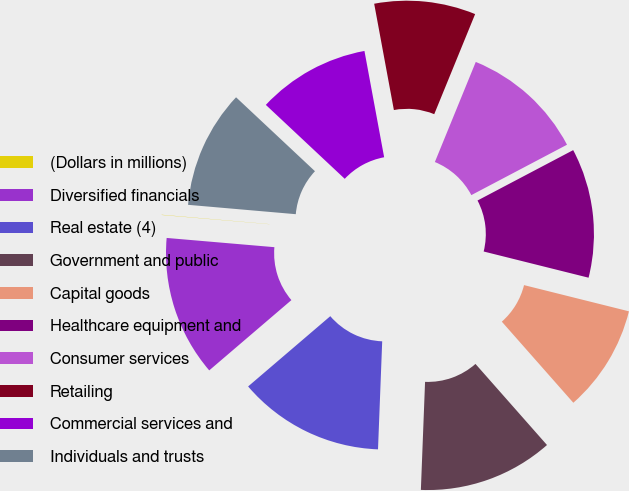<chart> <loc_0><loc_0><loc_500><loc_500><pie_chart><fcel>(Dollars in millions)<fcel>Diversified financials<fcel>Real estate (4)<fcel>Government and public<fcel>Capital goods<fcel>Healthcare equipment and<fcel>Consumer services<fcel>Retailing<fcel>Commercial services and<fcel>Individuals and trusts<nl><fcel>0.02%<fcel>12.62%<fcel>13.12%<fcel>12.12%<fcel>9.6%<fcel>11.61%<fcel>11.11%<fcel>9.09%<fcel>10.1%<fcel>10.6%<nl></chart> 